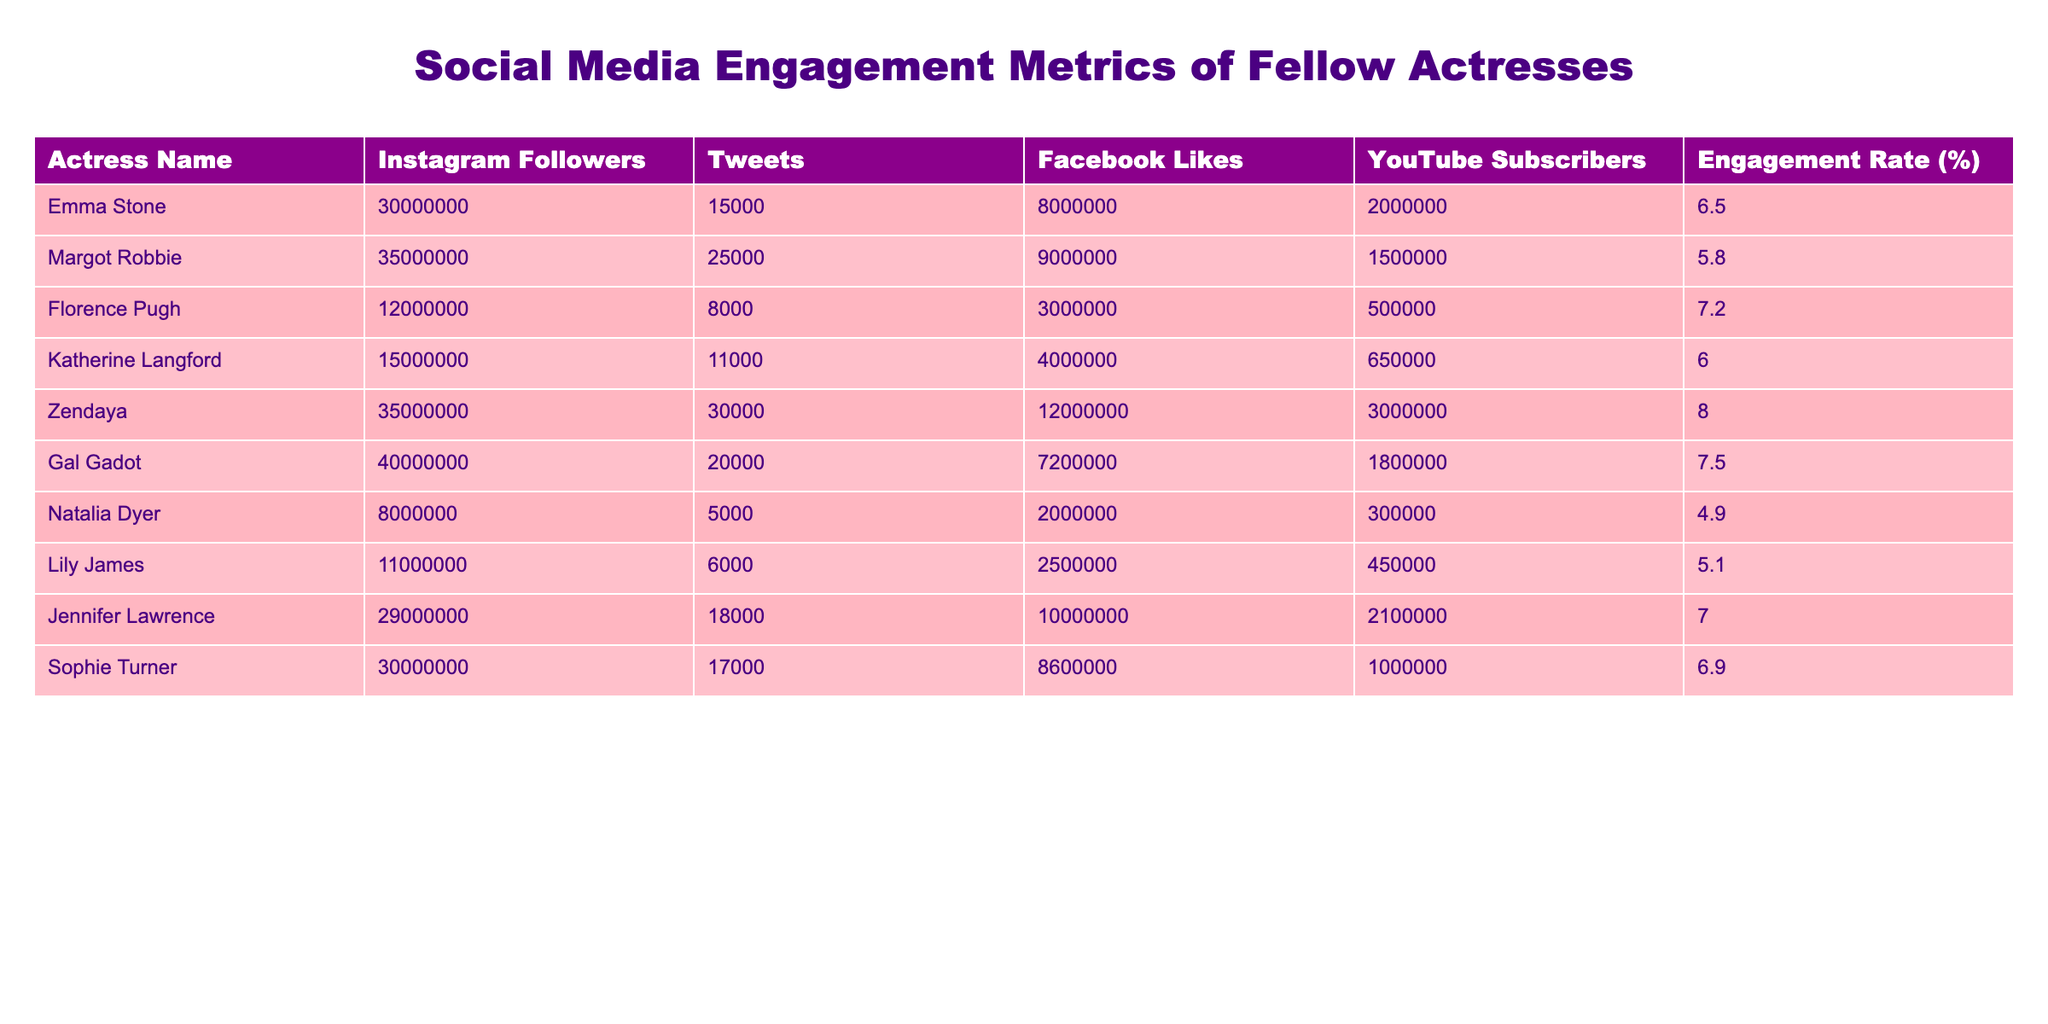What is the highest number of Instagram followers among the actresses? The highest number of Instagram followers is found by comparing the values in the "Instagram Followers" column. The highest value is 40,000,000, which belongs to Gal Gadot.
Answer: 40,000,000 How many Tweets did Zendaya post? By looking at the "Tweets" column for Zendaya, we see the value listed is 30,000.
Answer: 30,000 Which actress has the lowest Engagement Rate? To find the lowest Engagement Rate, we need to examine the "Engagement Rate (%)" column. The lowest value is 4.9%, which is for Natalia Dyer.
Answer: Natalia Dyer What is the average number of Facebook Likes across all actresses? To calculate the average, sum all the Facebook Likes (8,000,000 + 9,000,000 + 3,000,000 + 4,000,000 + 12,000,000 + 7,200,000 + 2,000,000 + 2,500,000 + 10,000,000 + 8,600,000) = 66,300,000. There are 10 actresses, therefore the average is 66,300,000 / 10 = 6,630,000.
Answer: 6,630,000 Does Emma Stone have more YouTube Subscribers than Margot Robbie? Comparing the values from the "YouTube Subscribers" column, Emma Stone has 2,000,000 and Margot Robbie has 1,500,000. Since 2,000,000 is greater than 1,500,000, the statement is true.
Answer: Yes Who has the highest Engagement Rate and what is that rate? Looking through the "Engagement Rate (%)" column, Zendaya has the highest rate of 8.0%.
Answer: Zendaya, 8.0% If you combine the number of Instagram followers of Florence Pugh and Lily James, how many followers would that total? Florence Pugh has 12,000,000 and Lily James has 11,000,000. Adding these two together: 12,000,000 + 11,000,000 = 23,000,000.
Answer: 23,000,000 How many actresses have more than 20,000 Twitter posts? Reviewing the "Tweets" column, Zendaya (30,000), Margot Robbie (25,000), and Gal Gadot (20,000) are the only actresses with more than 20,000 tweets, totaling three actresses.
Answer: 3 Is Jennifer Lawrence's number of YouTube Subscribers greater than Katherine Langford's? Comparing the "YouTube Subscribers," Jennifer Lawrence has 2,100,000 and Katherine Langford has 650,000. Since 2,100,000 is greater than 650,000, the statement is true.
Answer: Yes 